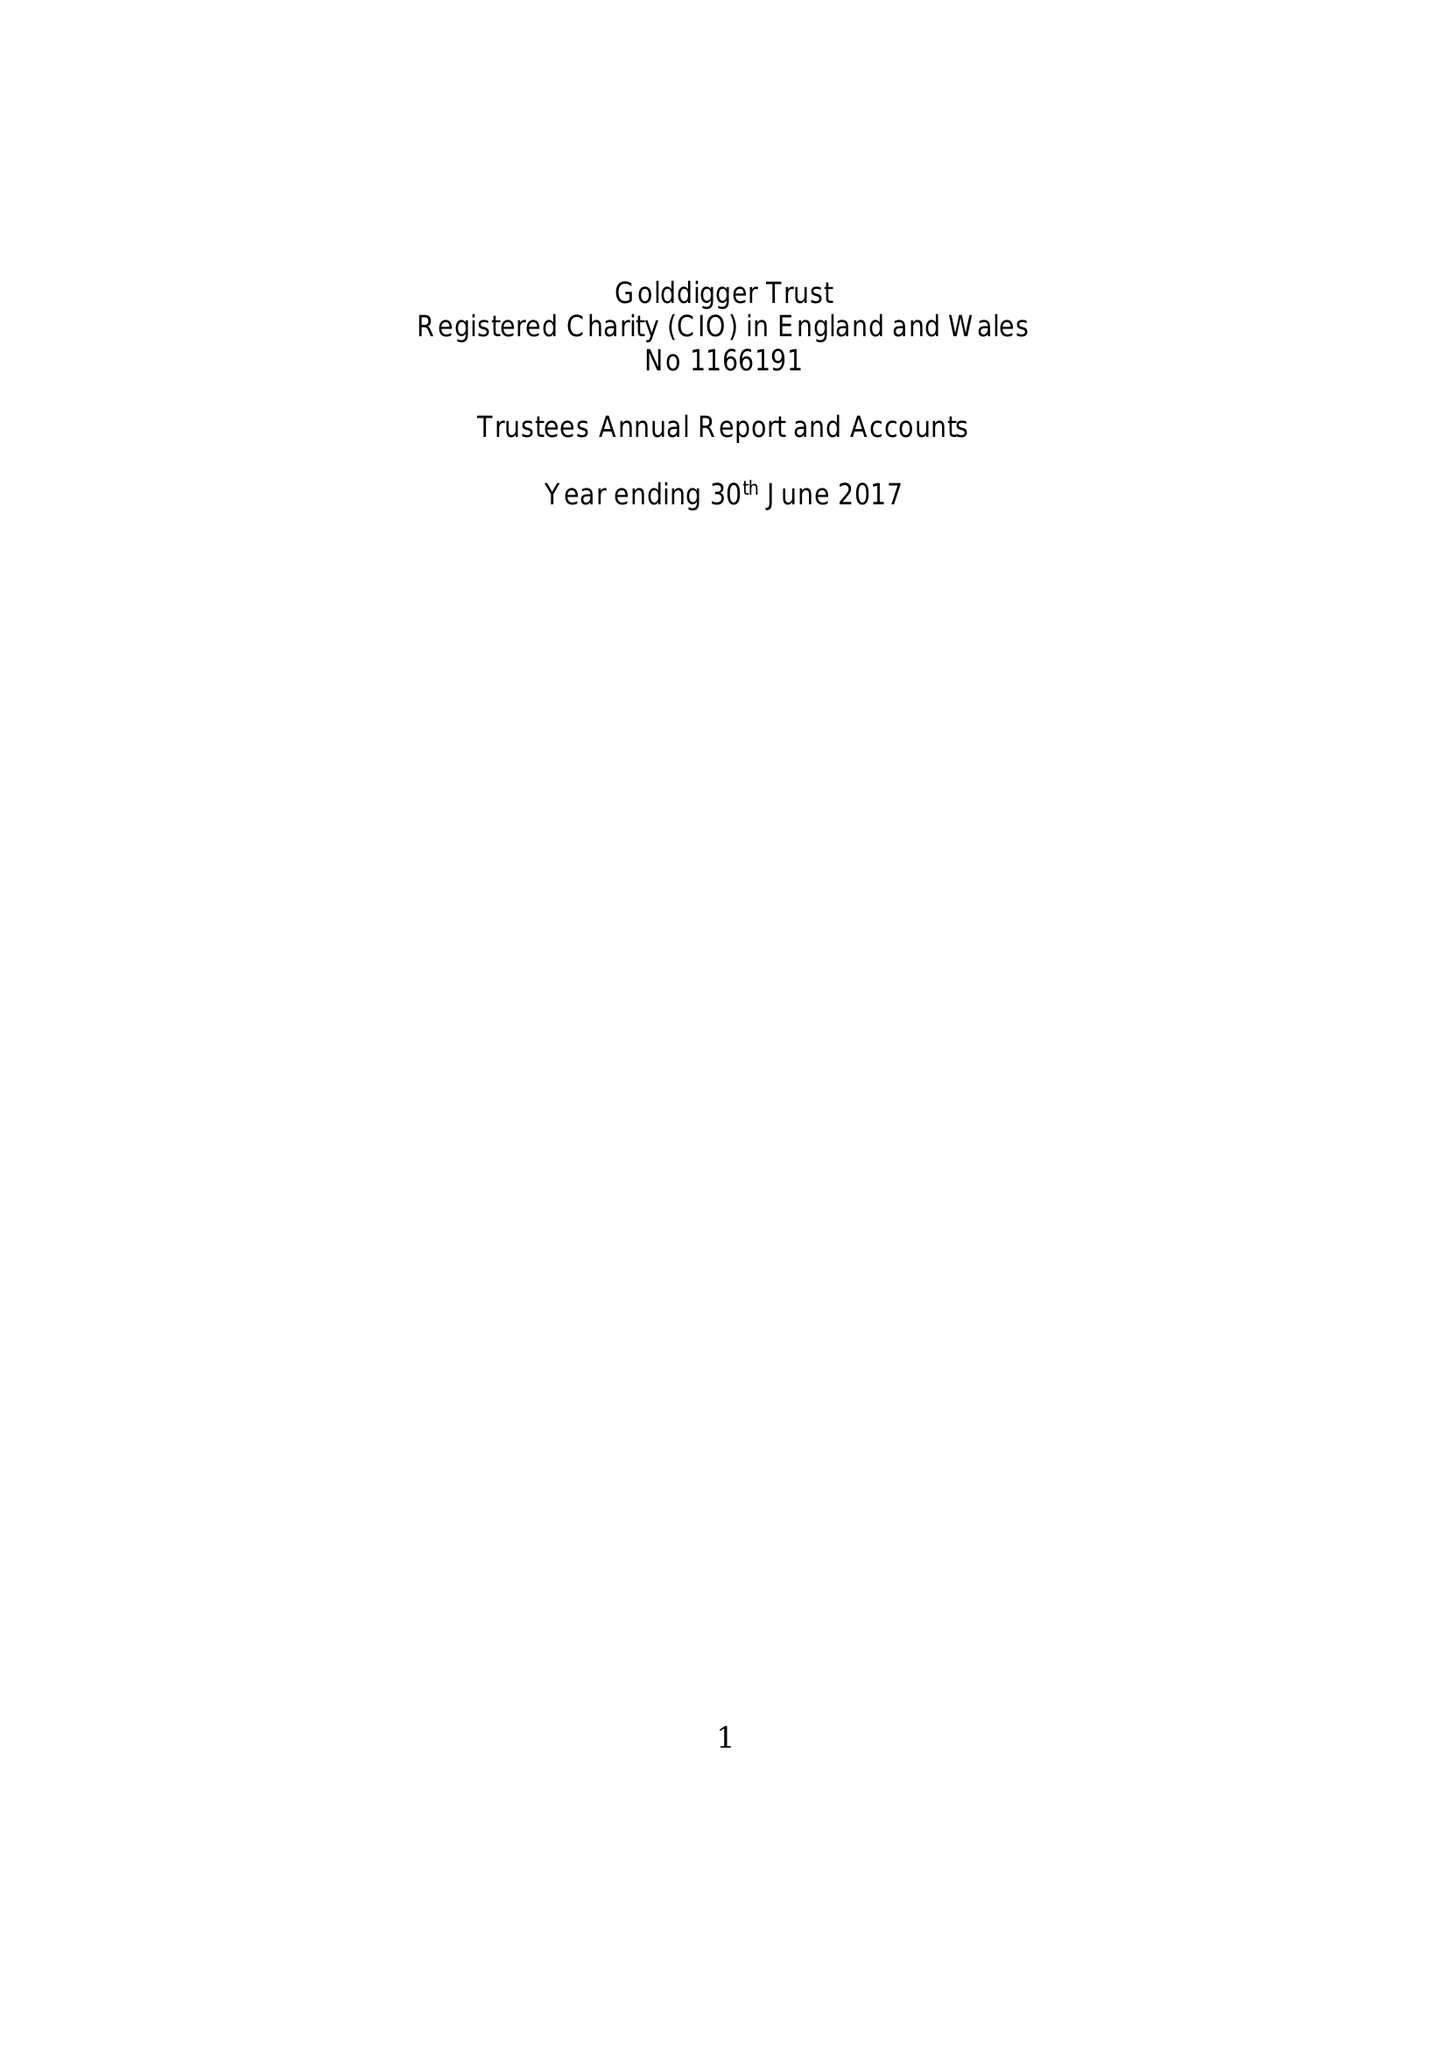What is the value for the address__street_line?
Answer the question using a single word or phrase. 10 PSALTER LANE 